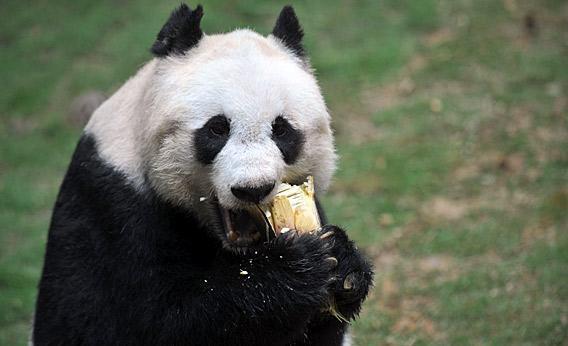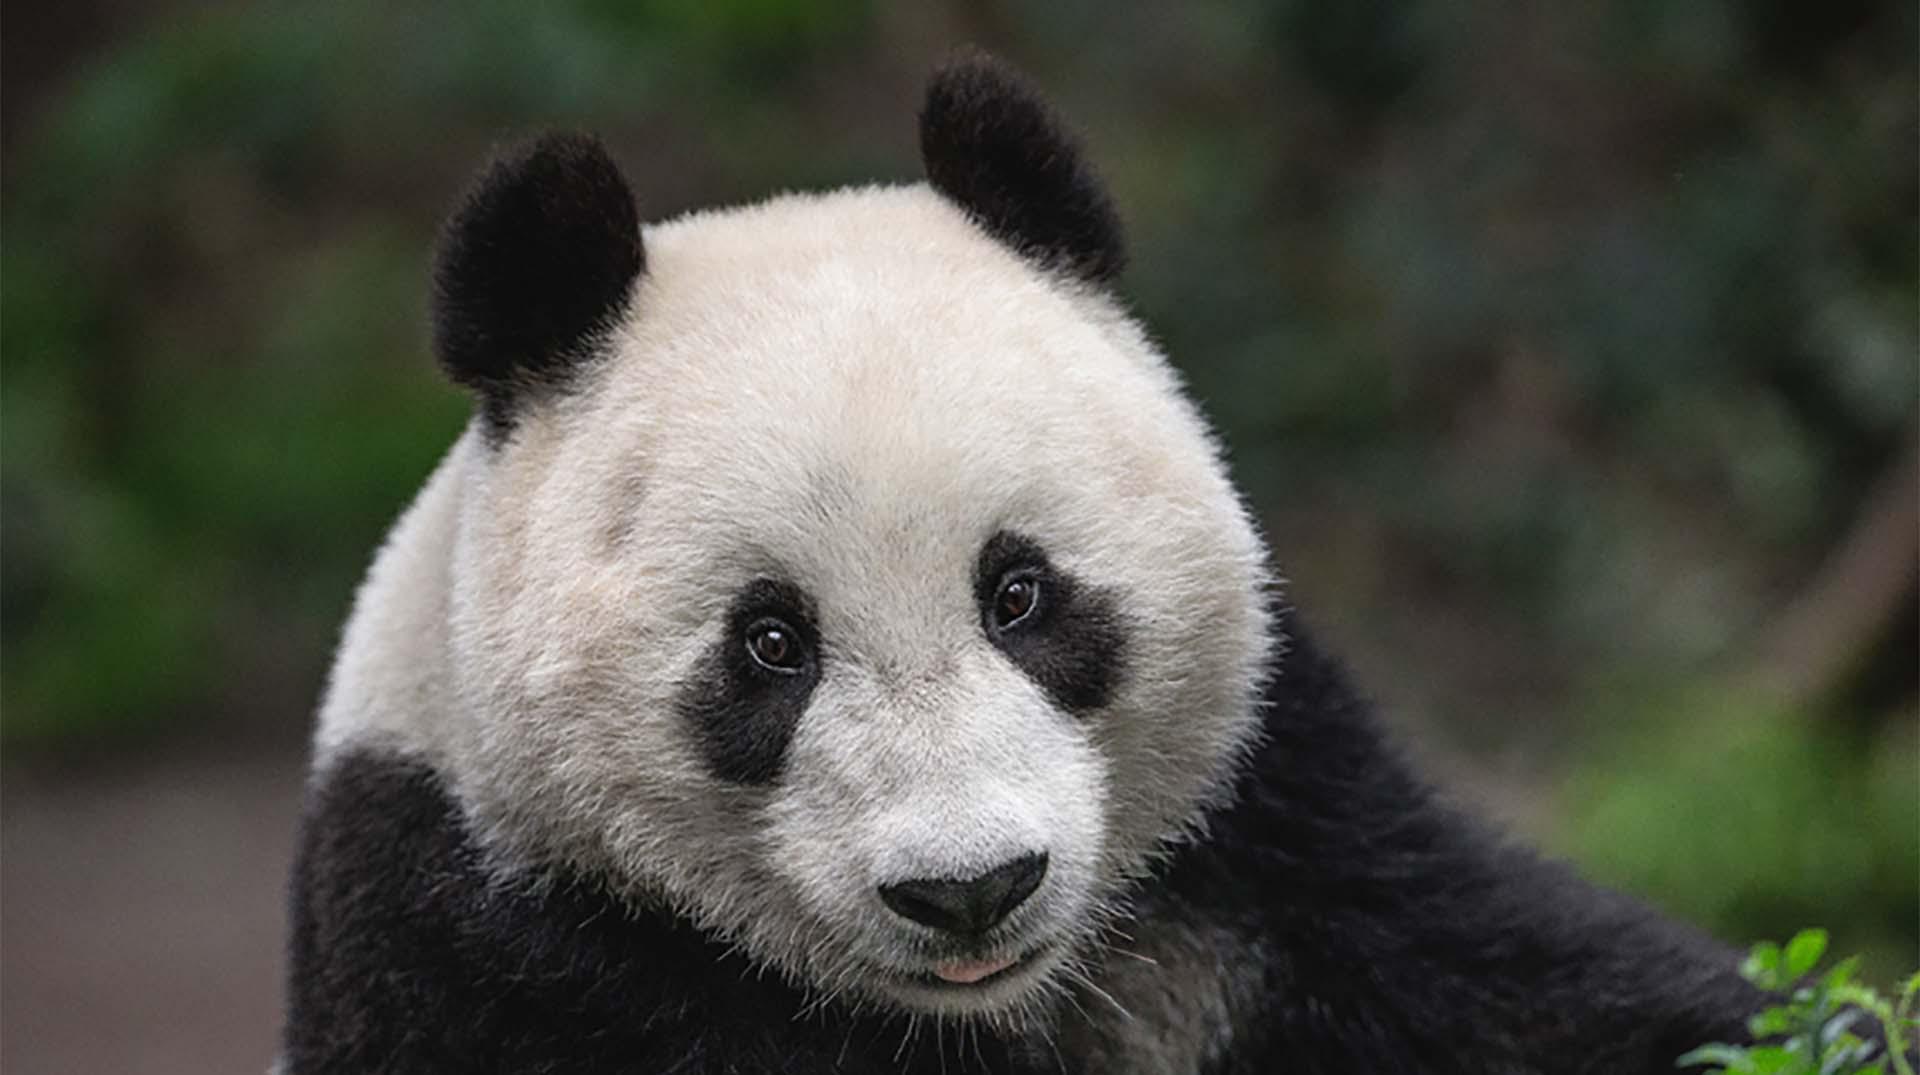The first image is the image on the left, the second image is the image on the right. Evaluate the accuracy of this statement regarding the images: "The panda in one of the images is standing on all fours in the grass.". Is it true? Answer yes or no. No. The first image is the image on the left, the second image is the image on the right. Assess this claim about the two images: "The panda in the left photo is holding a piece of wood in its paw.". Correct or not? Answer yes or no. Yes. 